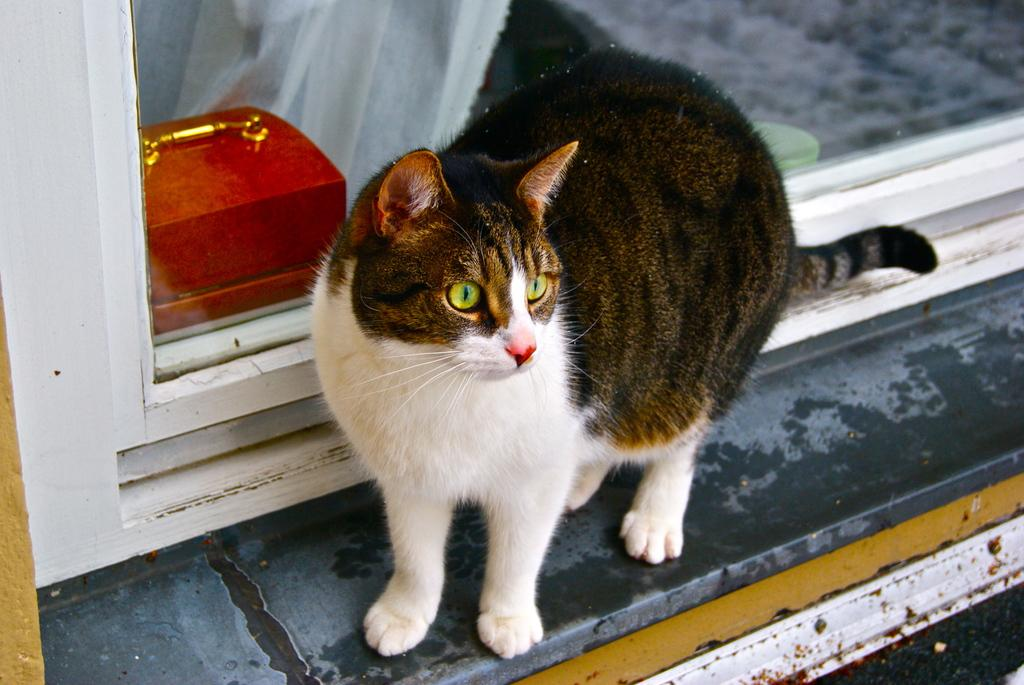What animal is present in the image? There is a cat in the image. Where is the cat located in the image? The cat is at a window. What can be seen through the window in the image? There is a box visible through the window. What type of boats are being served for dinner in the image? There are no boats or dinner present in the image; it features a cat at a window with a box visible through it. 